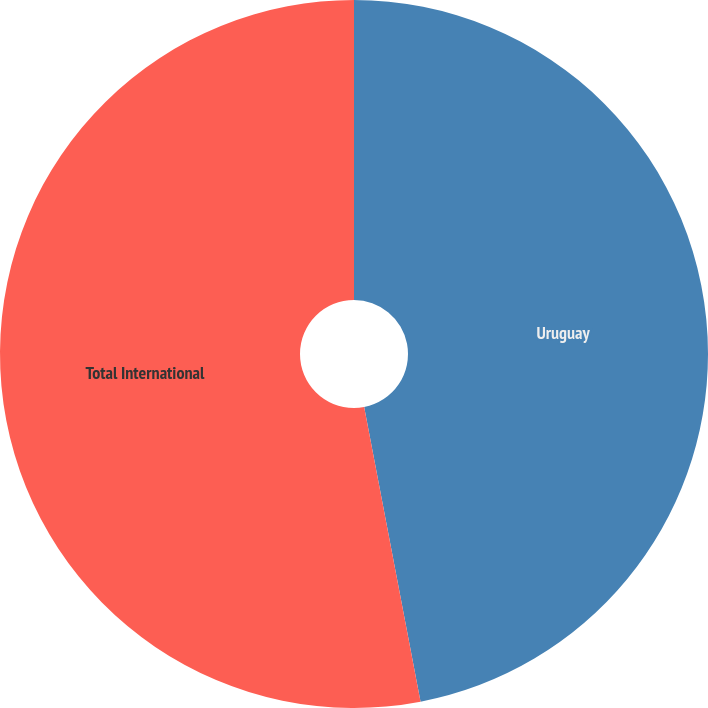<chart> <loc_0><loc_0><loc_500><loc_500><pie_chart><fcel>Uruguay<fcel>Total International<nl><fcel>46.99%<fcel>53.01%<nl></chart> 